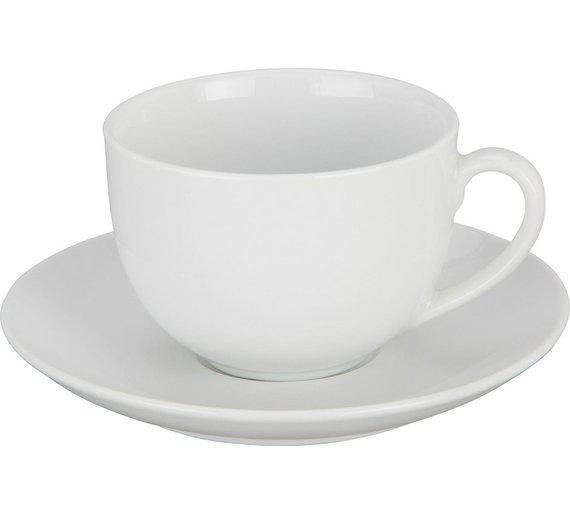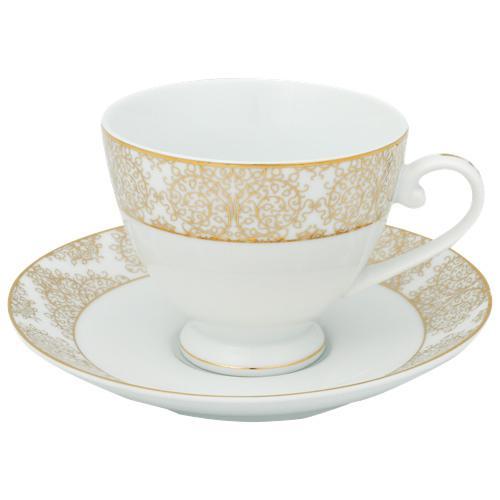The first image is the image on the left, the second image is the image on the right. Assess this claim about the two images: "An image contains exactly four cups on saucers.". Correct or not? Answer yes or no. No. The first image is the image on the left, the second image is the image on the right. For the images displayed, is the sentence "There are two teacup and saucer sets" factually correct? Answer yes or no. Yes. 